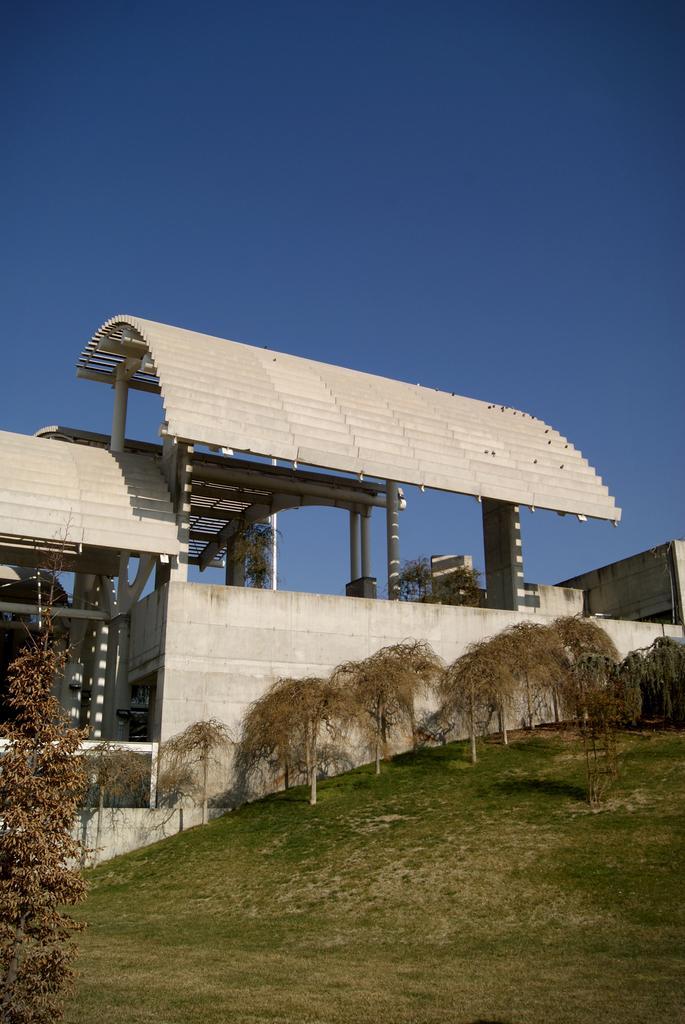How would you summarize this image in a sentence or two? At the center of the image there is a building, in front of the building there are trees and grass on the surface and there are a few plant pots on the wall of a building. In the background there is the sky. 